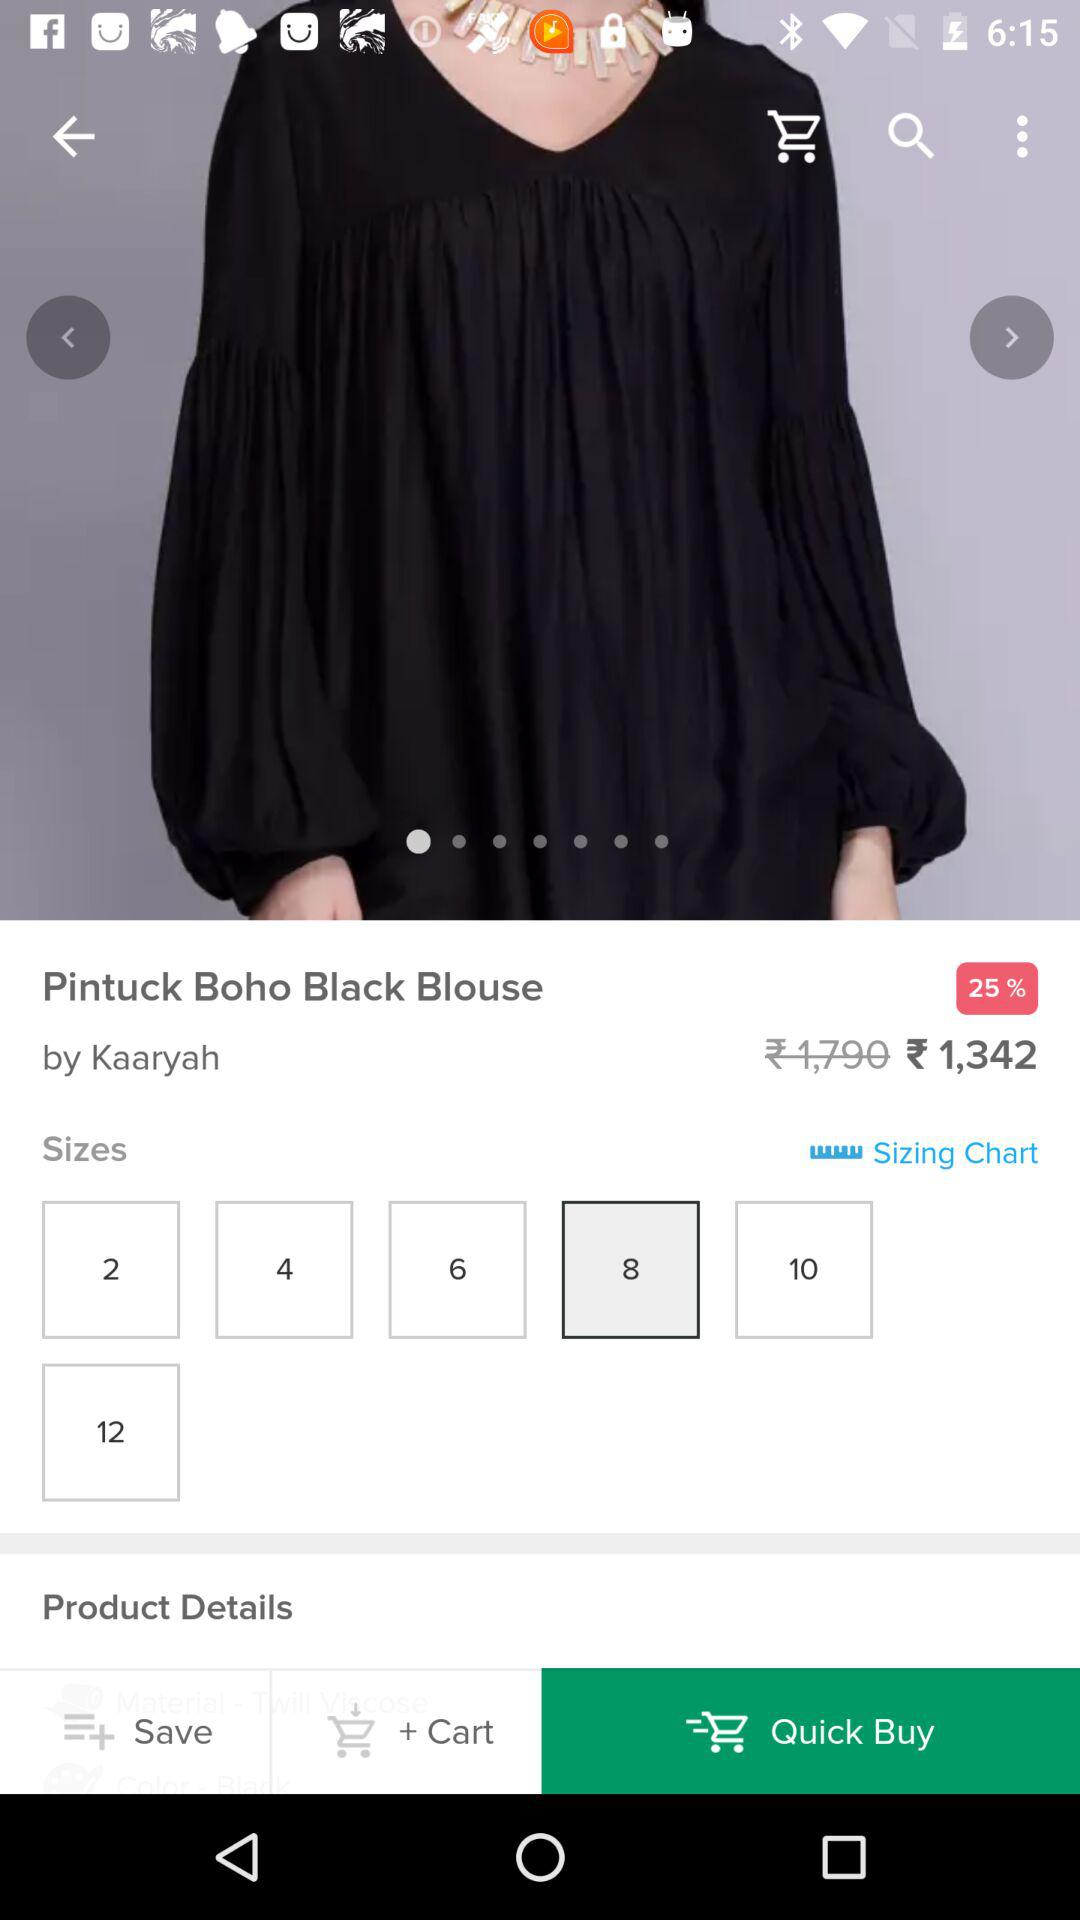How much is the blouse discounted by?
Answer the question using a single word or phrase. 25% 